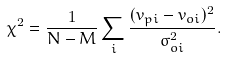Convert formula to latex. <formula><loc_0><loc_0><loc_500><loc_500>\chi ^ { 2 } = \frac { 1 } { N - M } \sum _ { i } \frac { ( v _ { p i } - v _ { o i } ) ^ { 2 } } { \sigma _ { o i } ^ { 2 } } .</formula> 